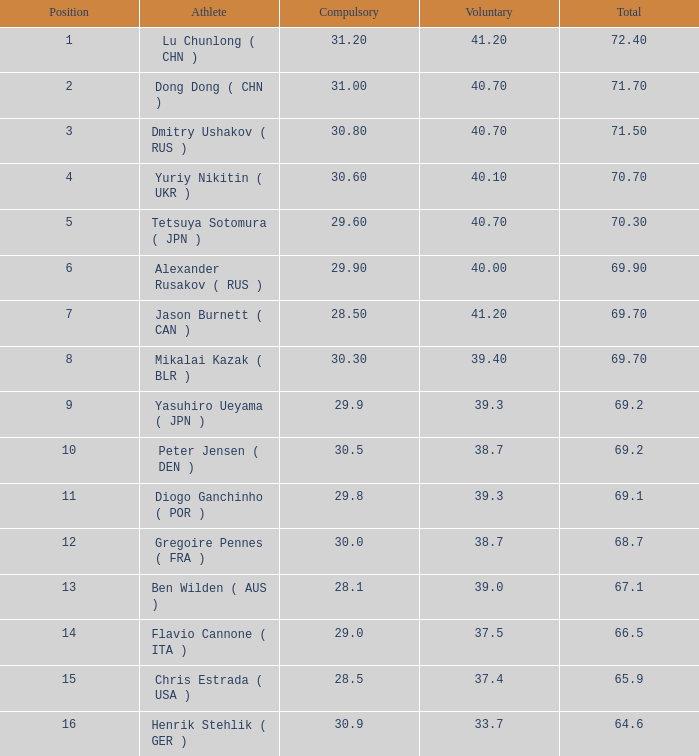What's the entirety of the spot of 1? None. Could you parse the entire table as a dict? {'header': ['Position', 'Athlete', 'Compulsory', 'Voluntary', 'Total'], 'rows': [['1', 'Lu Chunlong ( CHN )', '31.20', '41.20', '72.40'], ['2', 'Dong Dong ( CHN )', '31.00', '40.70', '71.70'], ['3', 'Dmitry Ushakov ( RUS )', '30.80', '40.70', '71.50'], ['4', 'Yuriy Nikitin ( UKR )', '30.60', '40.10', '70.70'], ['5', 'Tetsuya Sotomura ( JPN )', '29.60', '40.70', '70.30'], ['6', 'Alexander Rusakov ( RUS )', '29.90', '40.00', '69.90'], ['7', 'Jason Burnett ( CAN )', '28.50', '41.20', '69.70'], ['8', 'Mikalai Kazak ( BLR )', '30.30', '39.40', '69.70'], ['9', 'Yasuhiro Ueyama ( JPN )', '29.9', '39.3', '69.2'], ['10', 'Peter Jensen ( DEN )', '30.5', '38.7', '69.2'], ['11', 'Diogo Ganchinho ( POR )', '29.8', '39.3', '69.1'], ['12', 'Gregoire Pennes ( FRA )', '30.0', '38.7', '68.7'], ['13', 'Ben Wilden ( AUS )', '28.1', '39.0', '67.1'], ['14', 'Flavio Cannone ( ITA )', '29.0', '37.5', '66.5'], ['15', 'Chris Estrada ( USA )', '28.5', '37.4', '65.9'], ['16', 'Henrik Stehlik ( GER )', '30.9', '33.7', '64.6']]} 